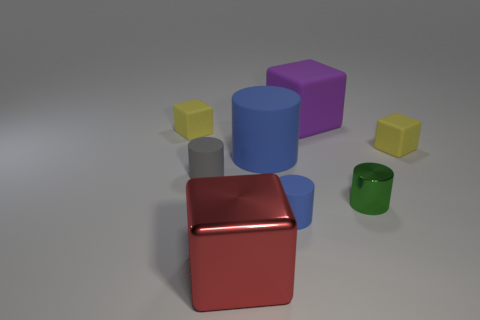There is a yellow matte cube that is right of the blue matte object that is in front of the blue thing that is behind the tiny gray matte object; what size is it?
Offer a terse response. Small. There is another shiny object that is the same shape as the small gray object; what color is it?
Your response must be concise. Green. Is the number of small yellow things on the right side of the metal cylinder greater than the number of large blue cubes?
Offer a terse response. Yes. Do the red thing and the shiny thing behind the big metal block have the same shape?
Your response must be concise. No. What is the size of the gray object that is the same shape as the green shiny object?
Keep it short and to the point. Small. Is the number of red blocks greater than the number of small cyan matte cylinders?
Make the answer very short. Yes. Does the large blue object have the same shape as the green metal object?
Your response must be concise. Yes. There is a large cube that is in front of the yellow matte block on the left side of the metal cube; what is its material?
Ensure brevity in your answer.  Metal. Do the shiny cylinder and the gray rubber cylinder have the same size?
Keep it short and to the point. Yes. There is a big cube behind the tiny gray cylinder; is there a blue rubber cylinder to the right of it?
Ensure brevity in your answer.  No. 